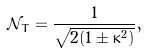<formula> <loc_0><loc_0><loc_500><loc_500>\mathcal { N } _ { T } = \frac { 1 } { \sqrt { 2 ( 1 \pm \kappa ^ { 2 } ) } } ,</formula> 